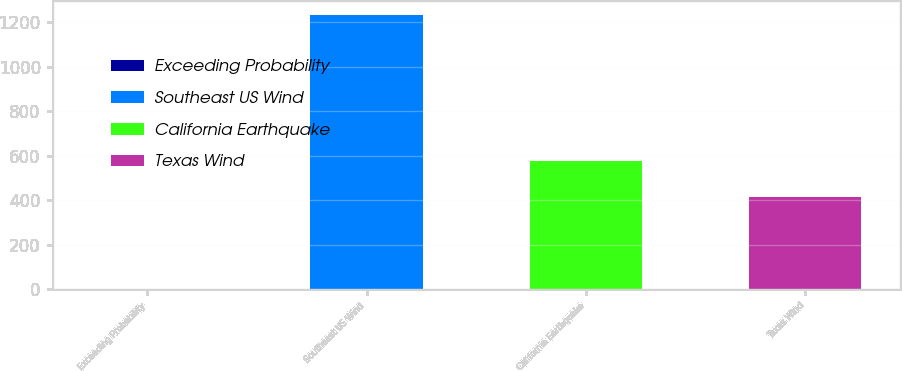<chart> <loc_0><loc_0><loc_500><loc_500><bar_chart><fcel>Exceeding Probability<fcel>Southeast US Wind<fcel>California Earthquake<fcel>Texas Wind<nl><fcel>2<fcel>1235<fcel>576<fcel>414<nl></chart> 